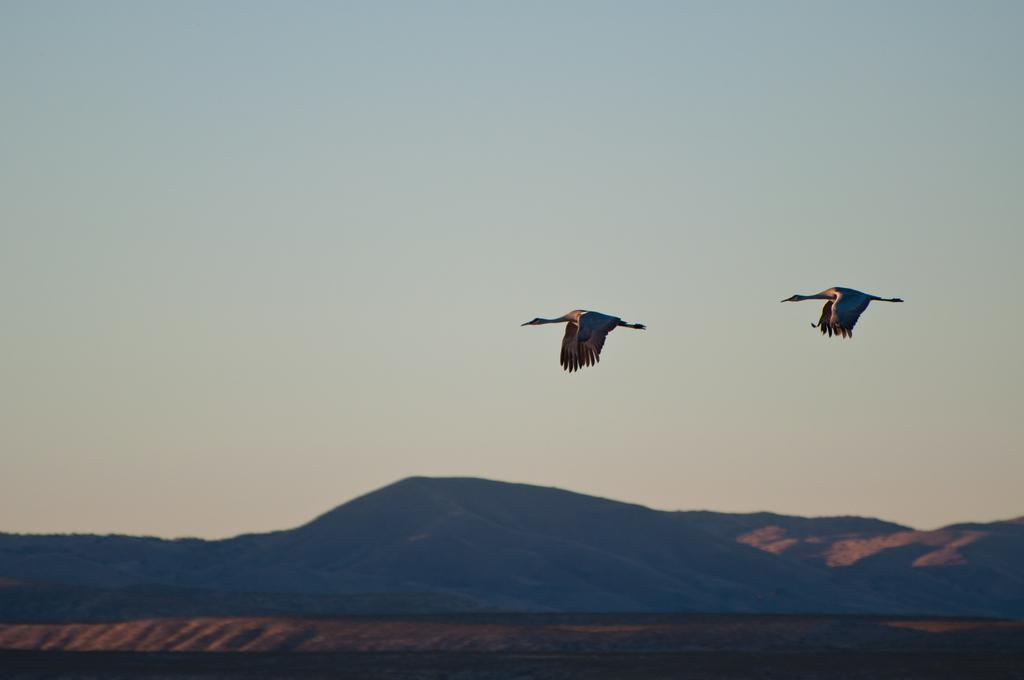What is happening in the sky in the image? Birds are flying in the air in the image. What type of landscape can be seen in the image? Hills are visible in the image. What else is visible in the image besides the birds and hills? The sky is visible in the image. What historical event is being commemorated by the birds in the image? There is no indication of a historical event in the image; it simply shows birds flying in the air. What type of lead is being used by the birds to fly in the image? The birds are not using any lead to fly in the image; they are flying naturally. 